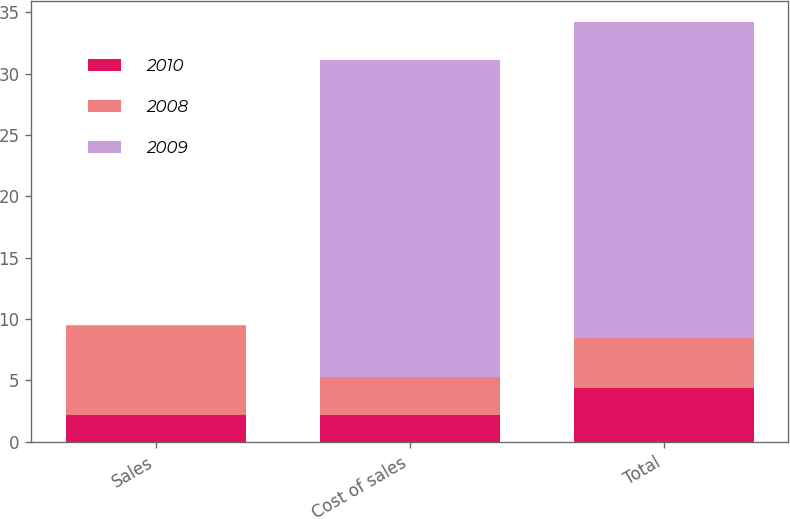Convert chart. <chart><loc_0><loc_0><loc_500><loc_500><stacked_bar_chart><ecel><fcel>Sales<fcel>Cost of sales<fcel>Total<nl><fcel>2010<fcel>2.2<fcel>2.2<fcel>4.4<nl><fcel>2008<fcel>7.2<fcel>3.1<fcel>4.1<nl><fcel>2009<fcel>0.1<fcel>25.8<fcel>25.7<nl></chart> 